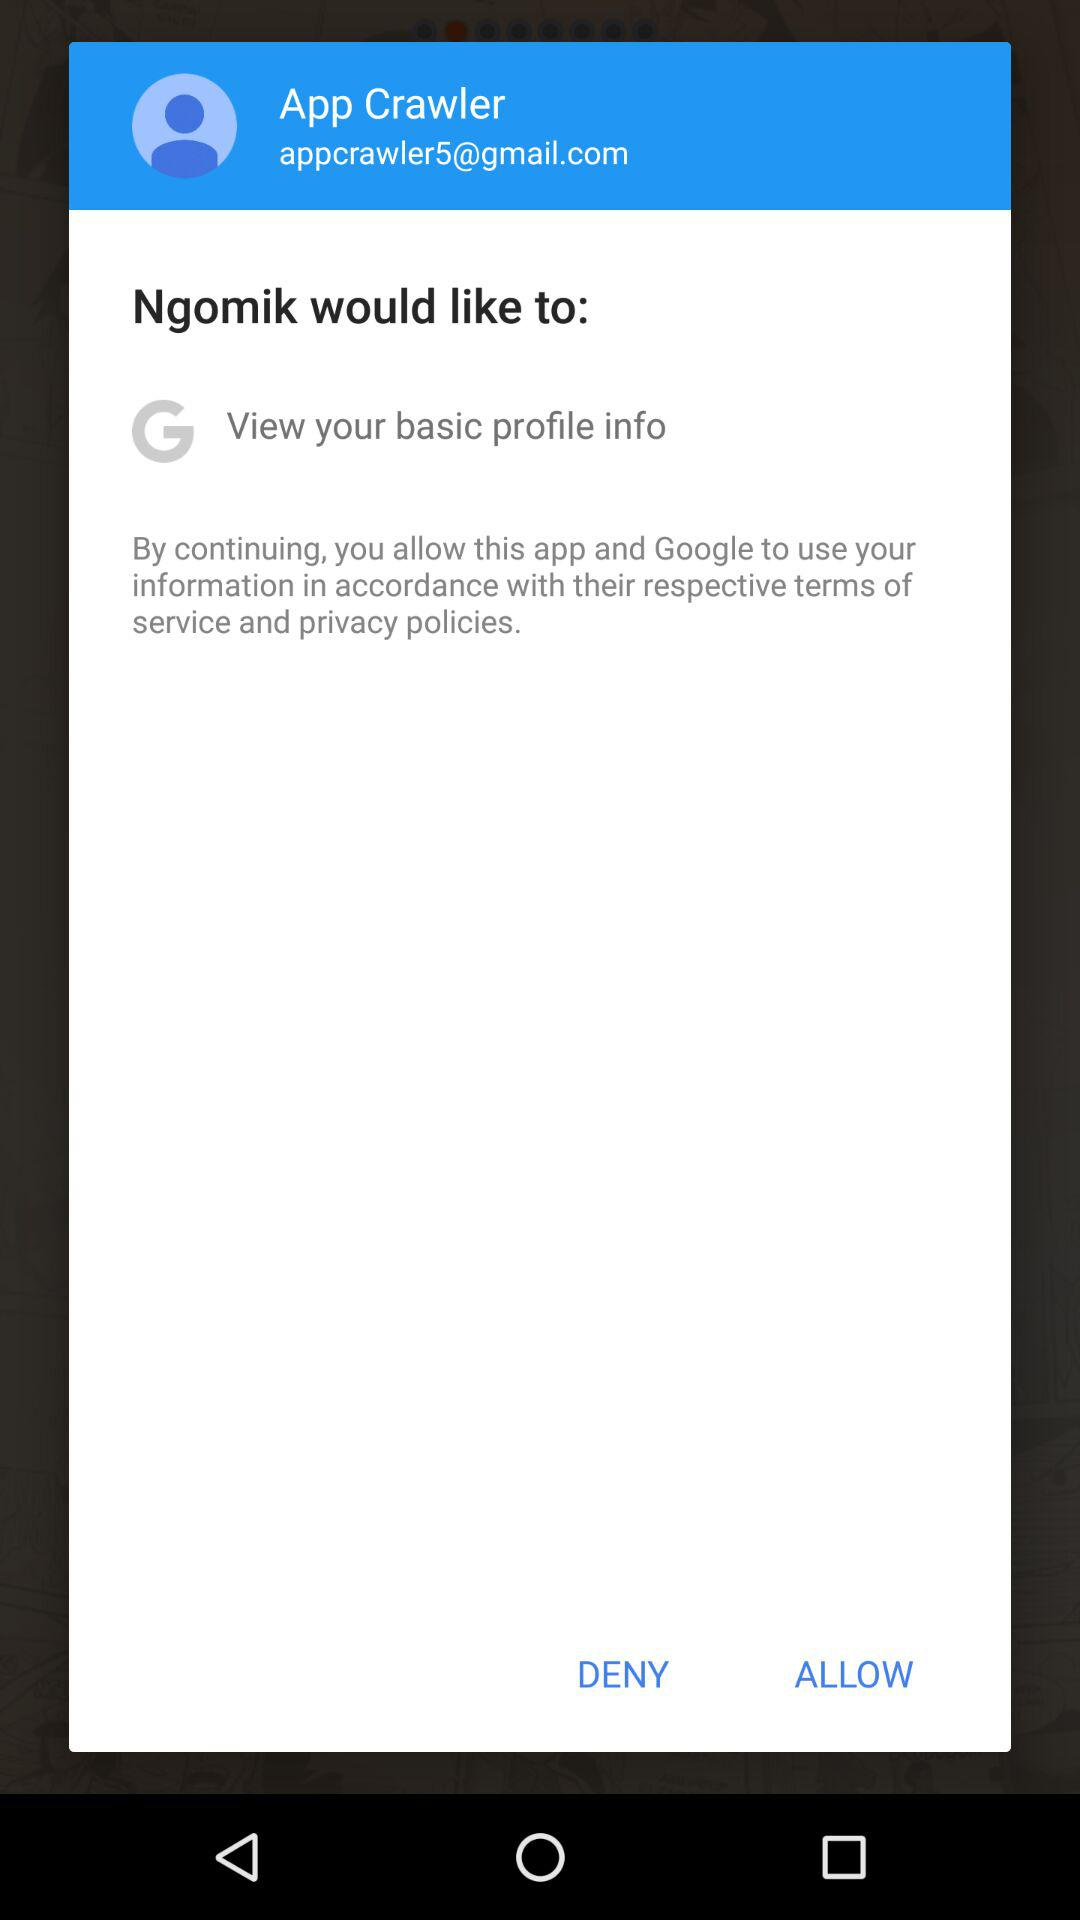What application would like to view my basic profile information? The application that would like to view your basic profile information is "Ngomik". 